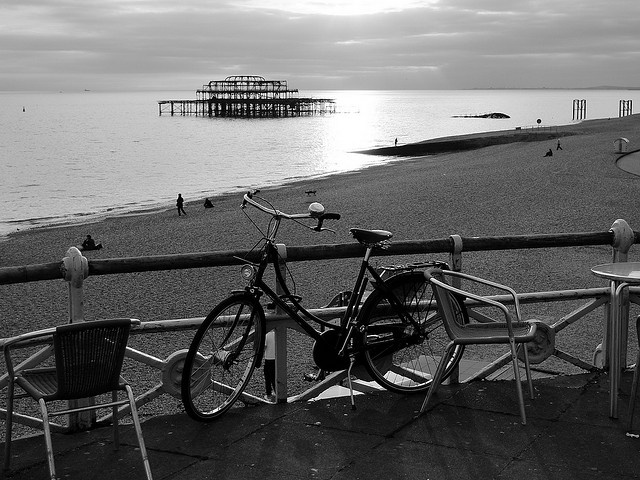Describe the objects in this image and their specific colors. I can see bicycle in darkgray, black, gray, and lightgray tones, chair in darkgray, black, gray, and lightgray tones, chair in darkgray, black, gray, and lightgray tones, dining table in darkgray, black, gray, and lightgray tones, and people in gray, black, and darkgray tones in this image. 